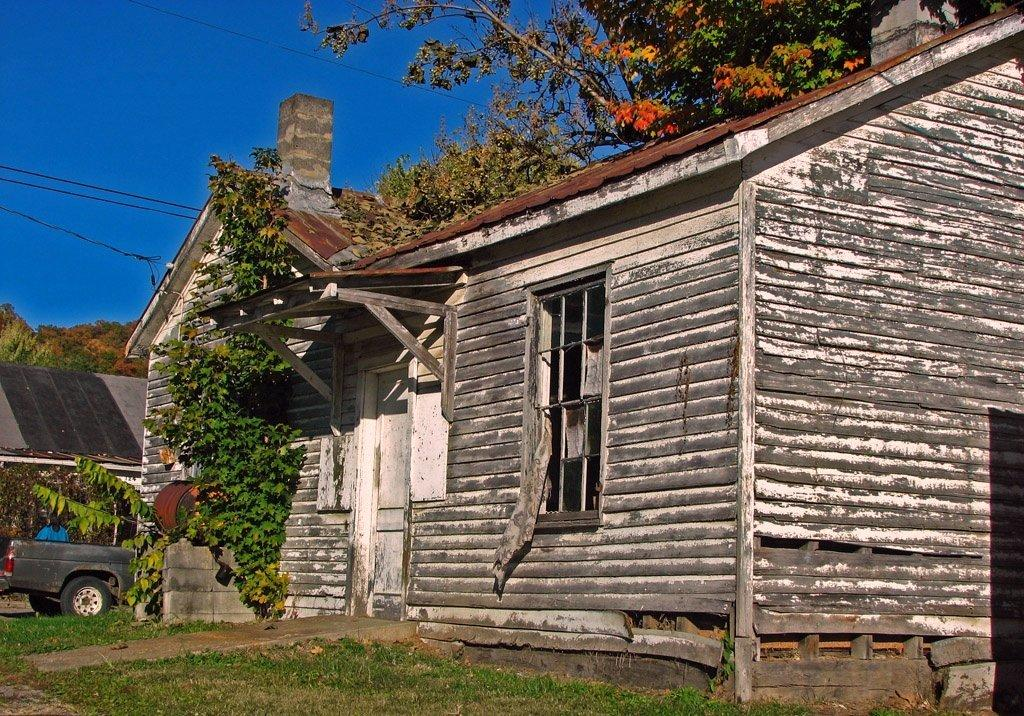What type of structures can be seen in the image? There are houses in the image. What else is present on the ground in the image? There is a vehicle on the ground in the image. What can be seen in the background of the image? There are trees and wires in the background of the image. What is visible above the houses and trees in the image? The sky is visible in the background of the image. How many roses are growing on the trees in the image? There are no roses visible on the trees in the image. What type of lumber is being used to construct the houses in the image? The image does not provide information about the type of lumber used to construct the houses. 